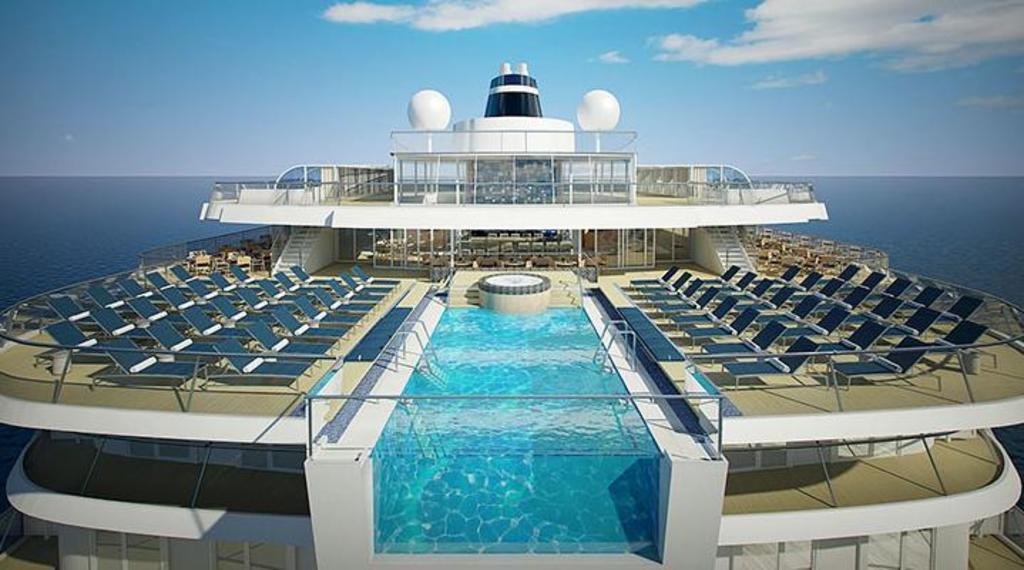How would you summarize this image in a sentence or two? In this image, we can see a ship. On the ship, on the right side and left side, we can see some chairs. In the middle of the ship, we can also see a water. In the background, we can see water in an ocean. At the top, we can see a sky which is a bit cloudy. 